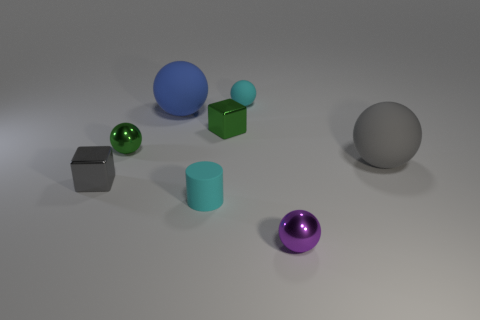What material is the large gray thing?
Provide a short and direct response. Rubber. What is the shape of the big gray matte object?
Keep it short and to the point. Sphere. How many big rubber objects have the same color as the tiny cylinder?
Ensure brevity in your answer.  0. There is a gray object that is to the right of the block that is right of the tiny cyan matte object in front of the small cyan matte sphere; what is it made of?
Provide a succinct answer. Rubber. How many yellow objects are either small cylinders or large matte things?
Give a very brief answer. 0. There is a gray object on the left side of the tiny matte thing behind the shiny cube behind the tiny gray object; what size is it?
Make the answer very short. Small. The purple thing that is the same shape as the large gray matte object is what size?
Keep it short and to the point. Small. What number of big objects are green cubes or cylinders?
Offer a terse response. 0. Are the big object that is on the left side of the small purple ball and the tiny cyan object in front of the gray matte object made of the same material?
Your answer should be very brief. Yes. What is the material of the tiny cube on the right side of the tiny gray block?
Offer a very short reply. Metal. 